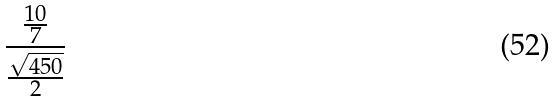<formula> <loc_0><loc_0><loc_500><loc_500>\frac { \frac { 1 0 } { 7 } } { \frac { \sqrt { 4 5 0 } } { 2 } }</formula> 